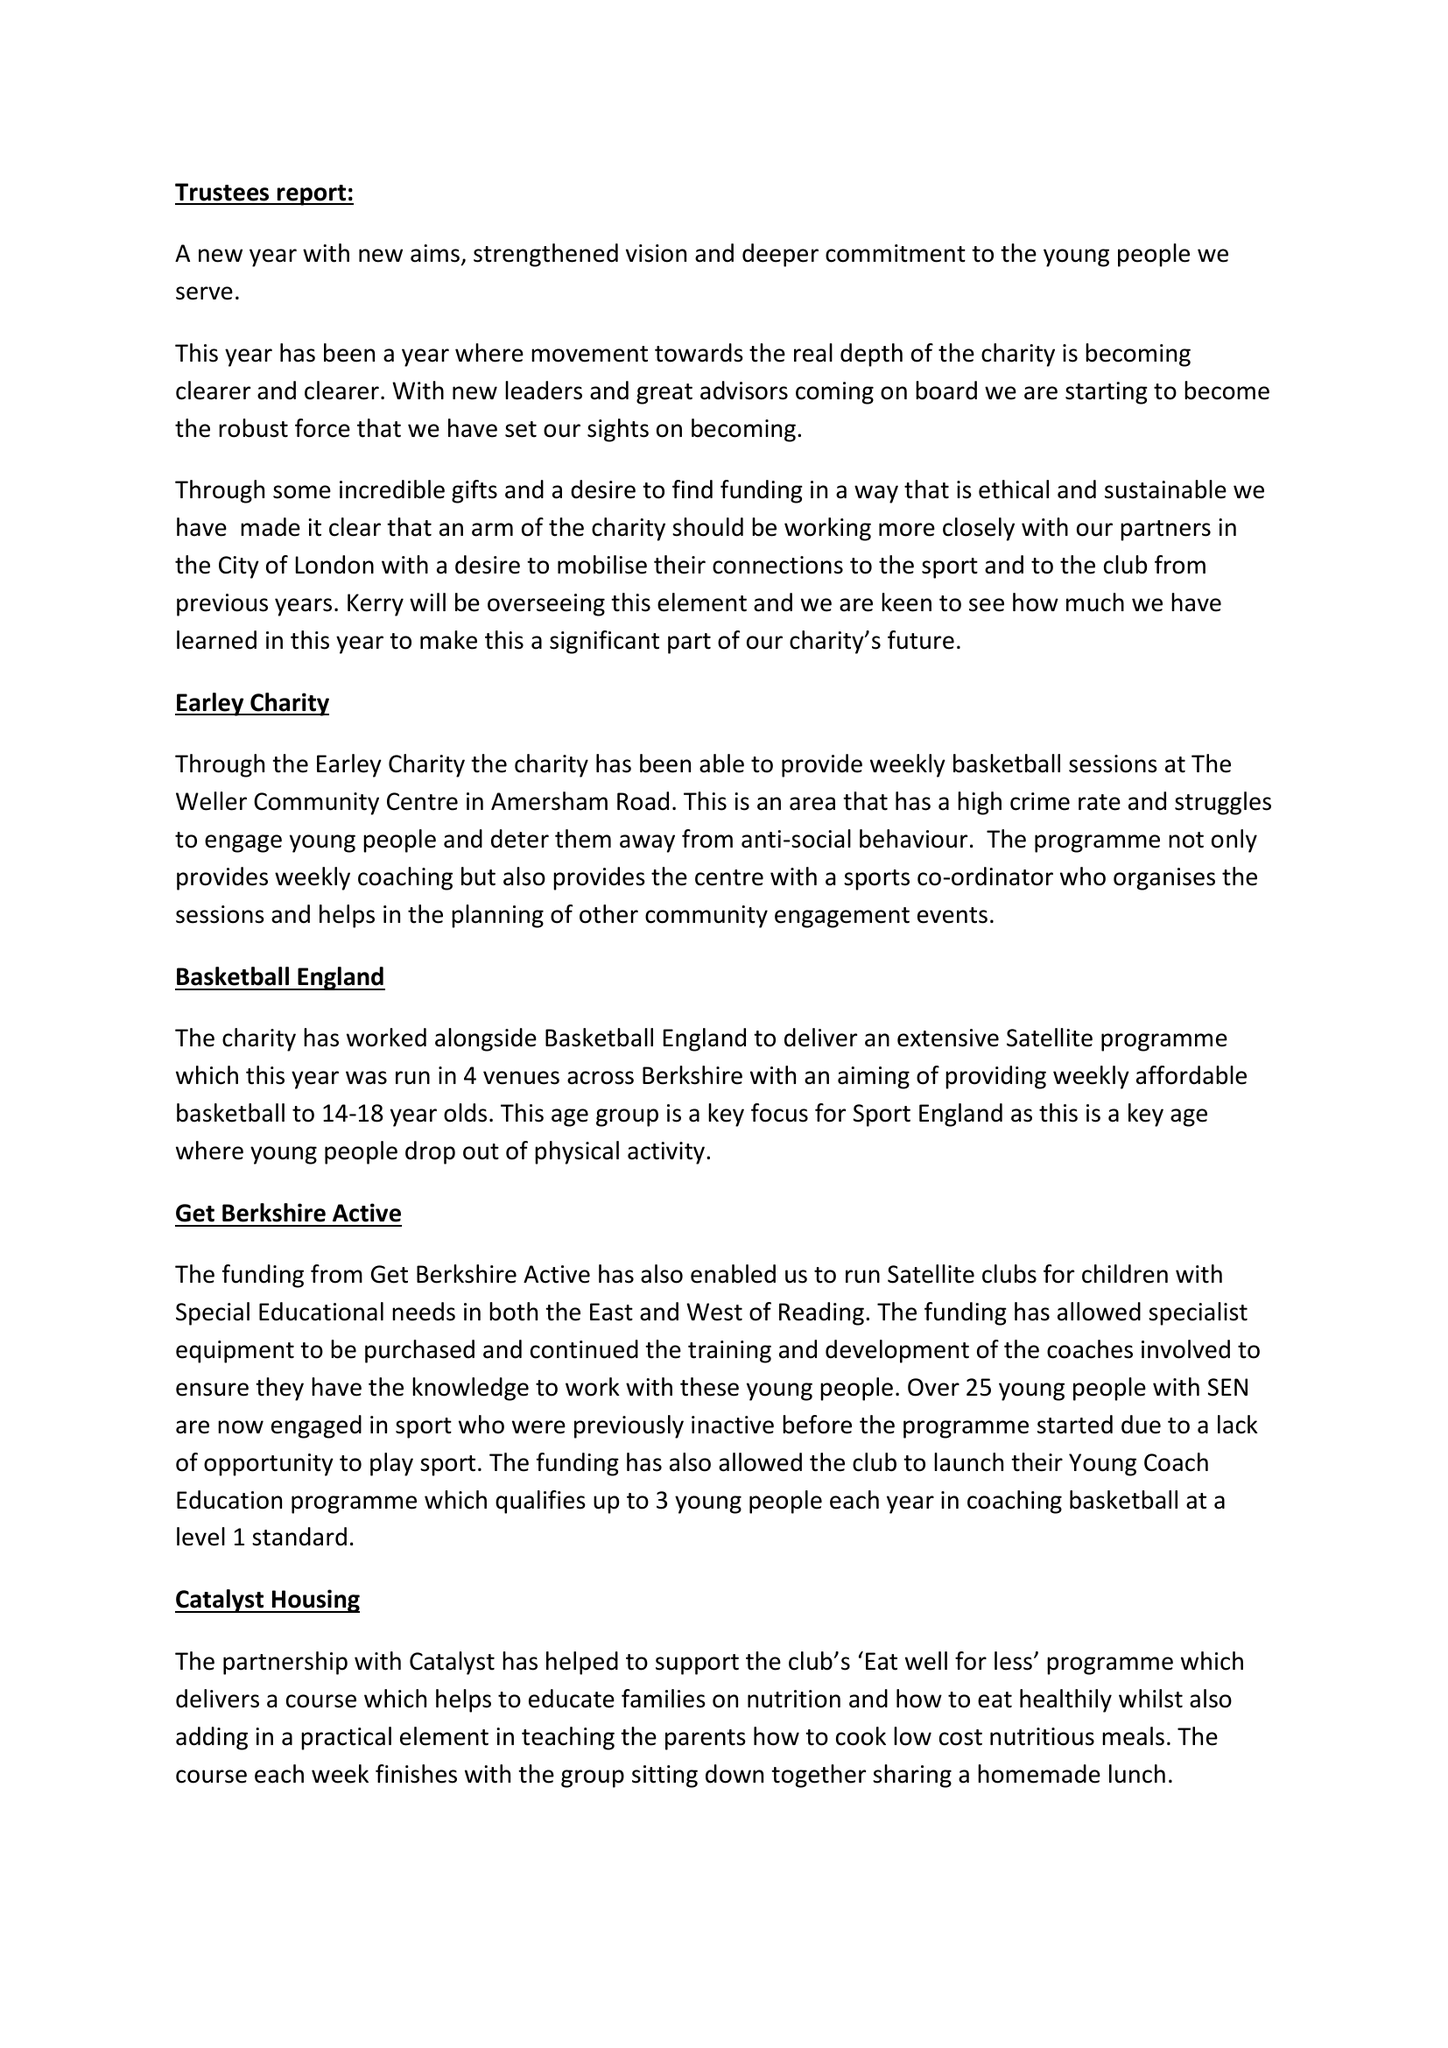What is the value for the charity_name?
Answer the question using a single word or phrase. Rockets Sport and Educational Foundation 